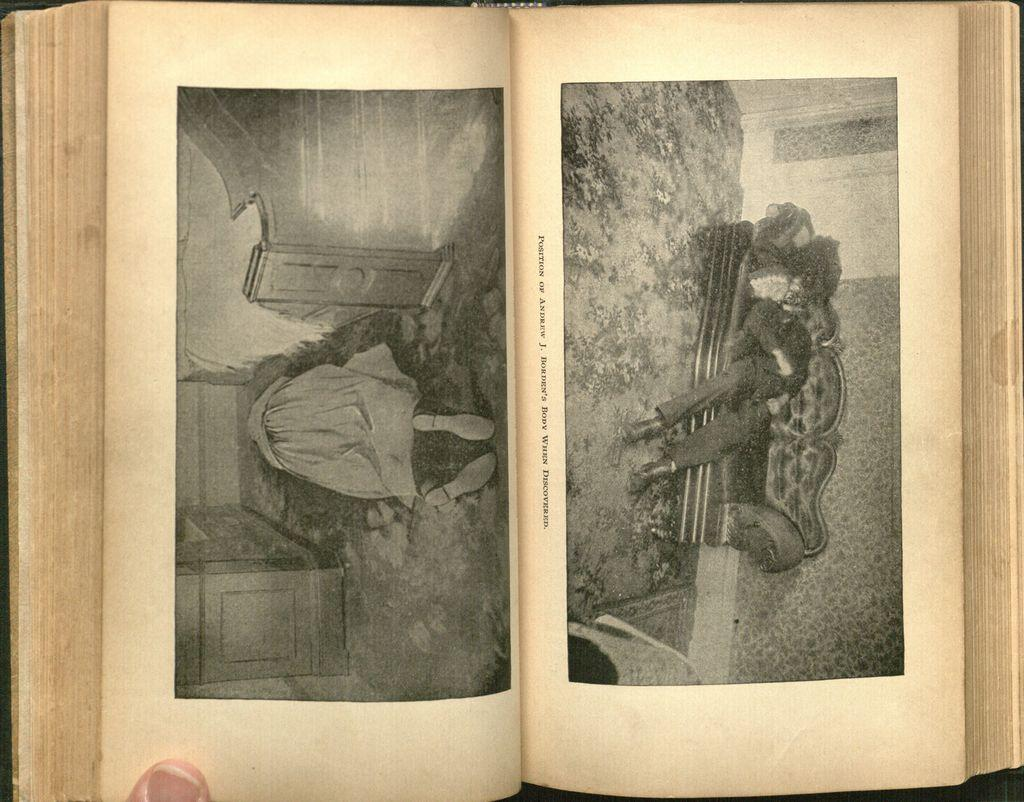What object can be seen in the image that is typically used for reading? There is a book in the image, which is commonly used for reading. Who or what is present in the image along with the book? There is a person in the image. What type of furniture is visible in the image? There is a sofa in the image. What part of the room can be seen in the image? The floor is visible in the image. What is the background of the image made of? There is a wall in the image. What can be found on the wall in the image? There are objects on the wall. What type of laborer is shown working on the wall in the image? There is no laborer present in the image, nor is anyone shown working on the wall. 